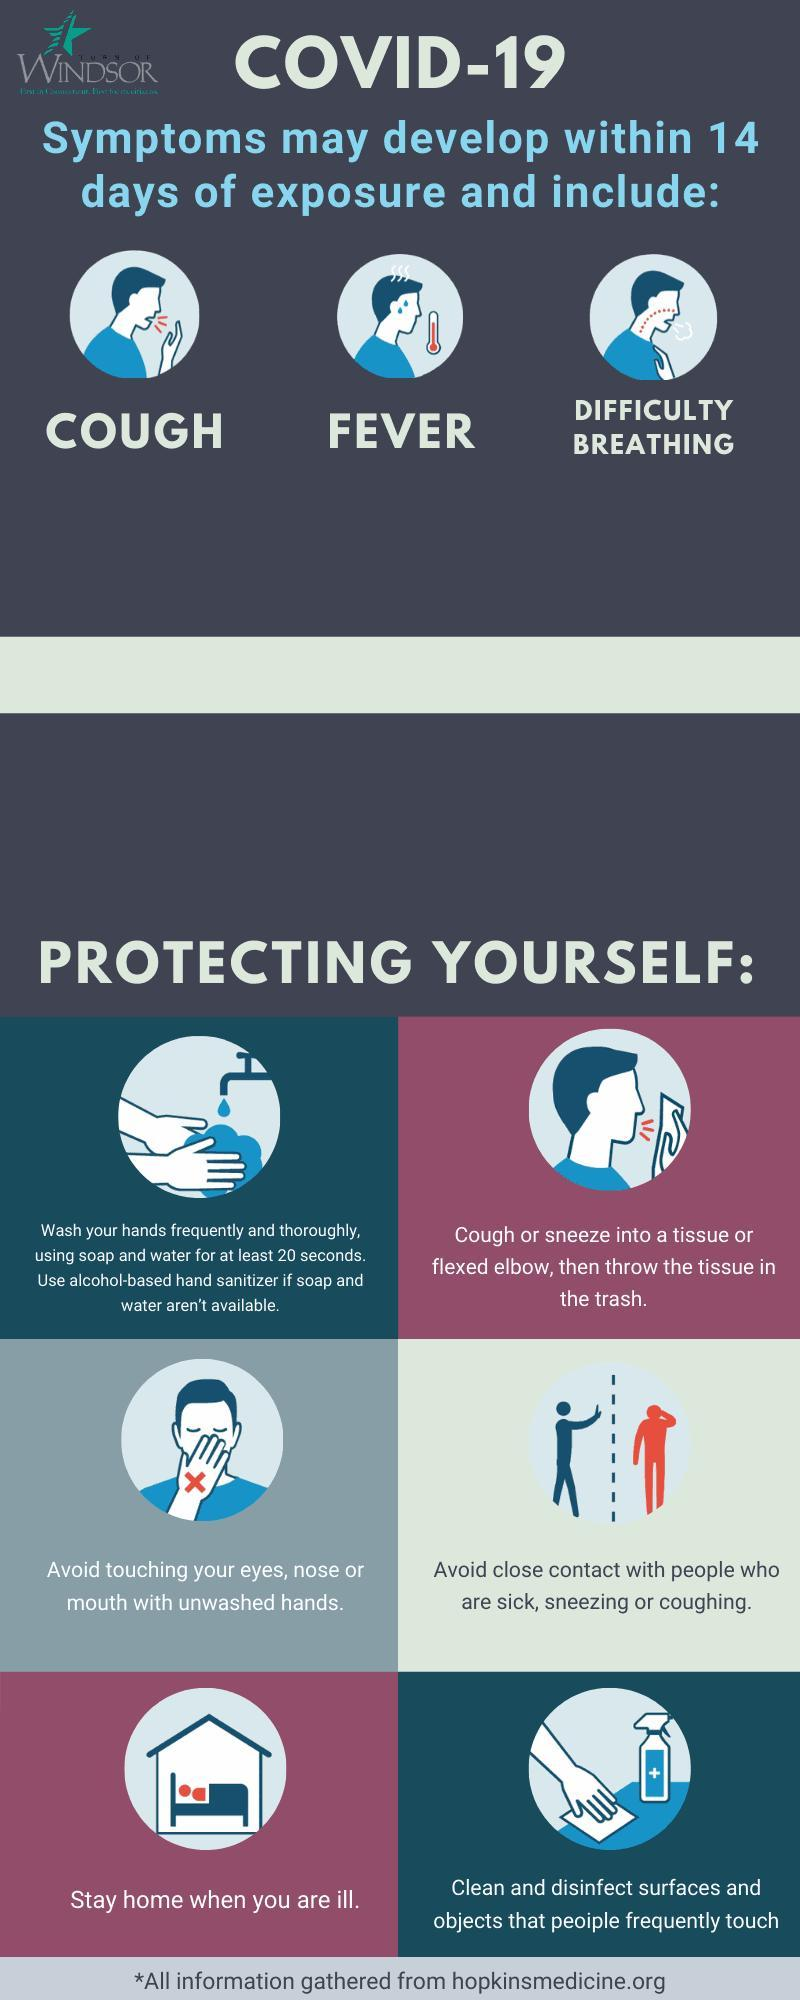What is the incubation period of the COVID-19 virus?
Answer the question with a short phrase. 14 days What are the symptoms of COVID-19  other than cough & difficulty breathing? FEVER 